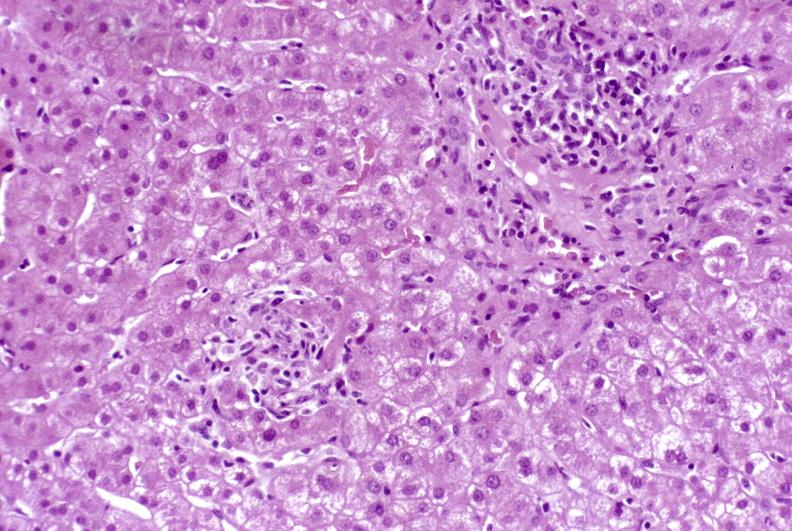what does this image show?
Answer the question using a single word or phrase. Granulomas 